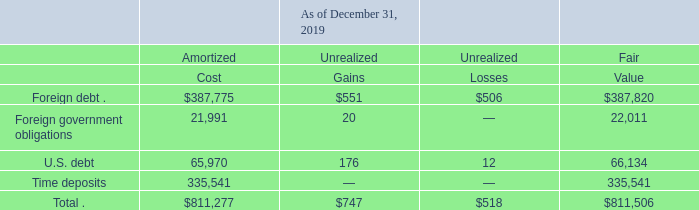During the year ended December 31, 2019, we sold marketable securities for proceeds of $52.0 million and realized no gain or loss on such sales. During the years ended December 31, 2018 and 2017, we sold marketable securities for proceeds of $10.8 million and $118.3 million, respectively, and realized gains of less than $0.1 million on such sales in each respective period. See Note 11. “Fair Value Measurements” to our consolidated financial statements for information about the fair value of our marketable securities.
The following tables summarize the unrealized gains and losses related to our available-for-sale marketable securities, by major security type, as of December 31, 2019 and 2018 (in thousands):
As of December 31, 2019, we had no investments in a loss position for a period of time greater than 12 months. As of December 31, 2018, we identified 15 investments totaling $207.2 million that had been in a loss position for a period of time greater than 12 months with unrealized losses of $1.8 million. The unrealized losses were primarily due to increases in interest rates relative to rates at the time of purchase. Based on the underlying credit quality of the investments, we generally hold such securities until we recover our cost basis. Therefore, we did not consider these securities to be other-than-temporarily impaired.
What amount of proceeds was derived from selling marketable securities in 2019? During the year ended december 31, 2019, we sold marketable securities for proceeds of $52.0 million and realized no gain or loss on such sales. How many investments were at loss positions for greater than 12 months as at 31 December 2018? 15. What were the reasons for the unrealized losses as at 31 December 2018? The unrealized losses were primarily due to increases in interest rates relative to rates at the time of purchase. What percentage of the total amortized marketable securities is made up of amortized foreign debt?
Answer scale should be: percent. 387,775 / 811,277 
Answer: 47.8. What is the net gain/loss for U.S. debt?
Answer scale should be: thousand. 176 - 12 
Answer: 164. What percentage of the total fair value marketable securities is made up of fair value time deposits?
Answer scale should be: percent. 335,541 / 811,506 
Answer: 41.35. 